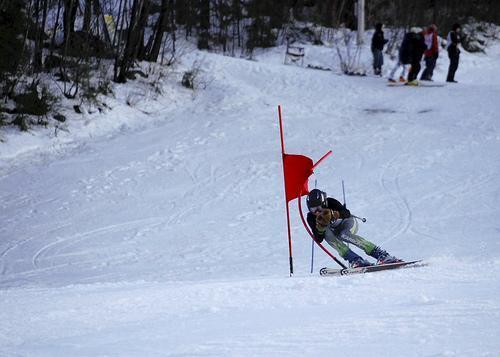How many skiers are pictured?
Give a very brief answer. 1. 